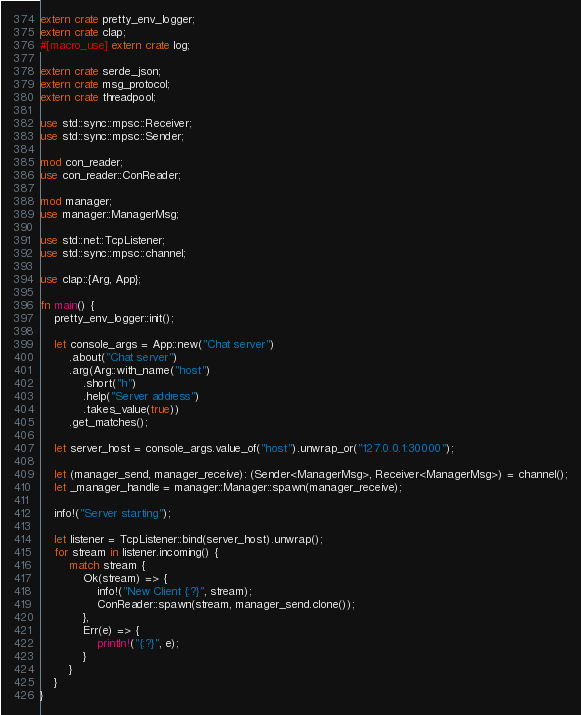Convert code to text. <code><loc_0><loc_0><loc_500><loc_500><_Rust_>extern crate pretty_env_logger;
extern crate clap;
#[macro_use] extern crate log;

extern crate serde_json;
extern crate msg_protocol;
extern crate threadpool;

use std::sync::mpsc::Receiver;
use std::sync::mpsc::Sender;

mod con_reader;
use con_reader::ConReader;

mod manager;
use manager::ManagerMsg;

use std::net::TcpListener;
use std::sync::mpsc::channel;

use clap::{Arg, App};

fn main() {
    pretty_env_logger::init();

    let console_args = App::new("Chat server")
        .about("Chat server")
        .arg(Arg::with_name("host")
            .short("h")
            .help("Server address")
            .takes_value(true))
        .get_matches();

    let server_host = console_args.value_of("host").unwrap_or("127.0.0.1:30000");

    let (manager_send, manager_receive): (Sender<ManagerMsg>, Receiver<ManagerMsg>) = channel();
    let _manager_handle = manager::Manager::spawn(manager_receive);

    info!("Server starting");

    let listener = TcpListener::bind(server_host).unwrap();
    for stream in listener.incoming() {
        match stream {
            Ok(stream) => {
                info!("New Client {:?}", stream);
                ConReader::spawn(stream, manager_send.clone());
            },
            Err(e) => {
                println!("{:?}", e);
            }
        }
    }
}
</code> 